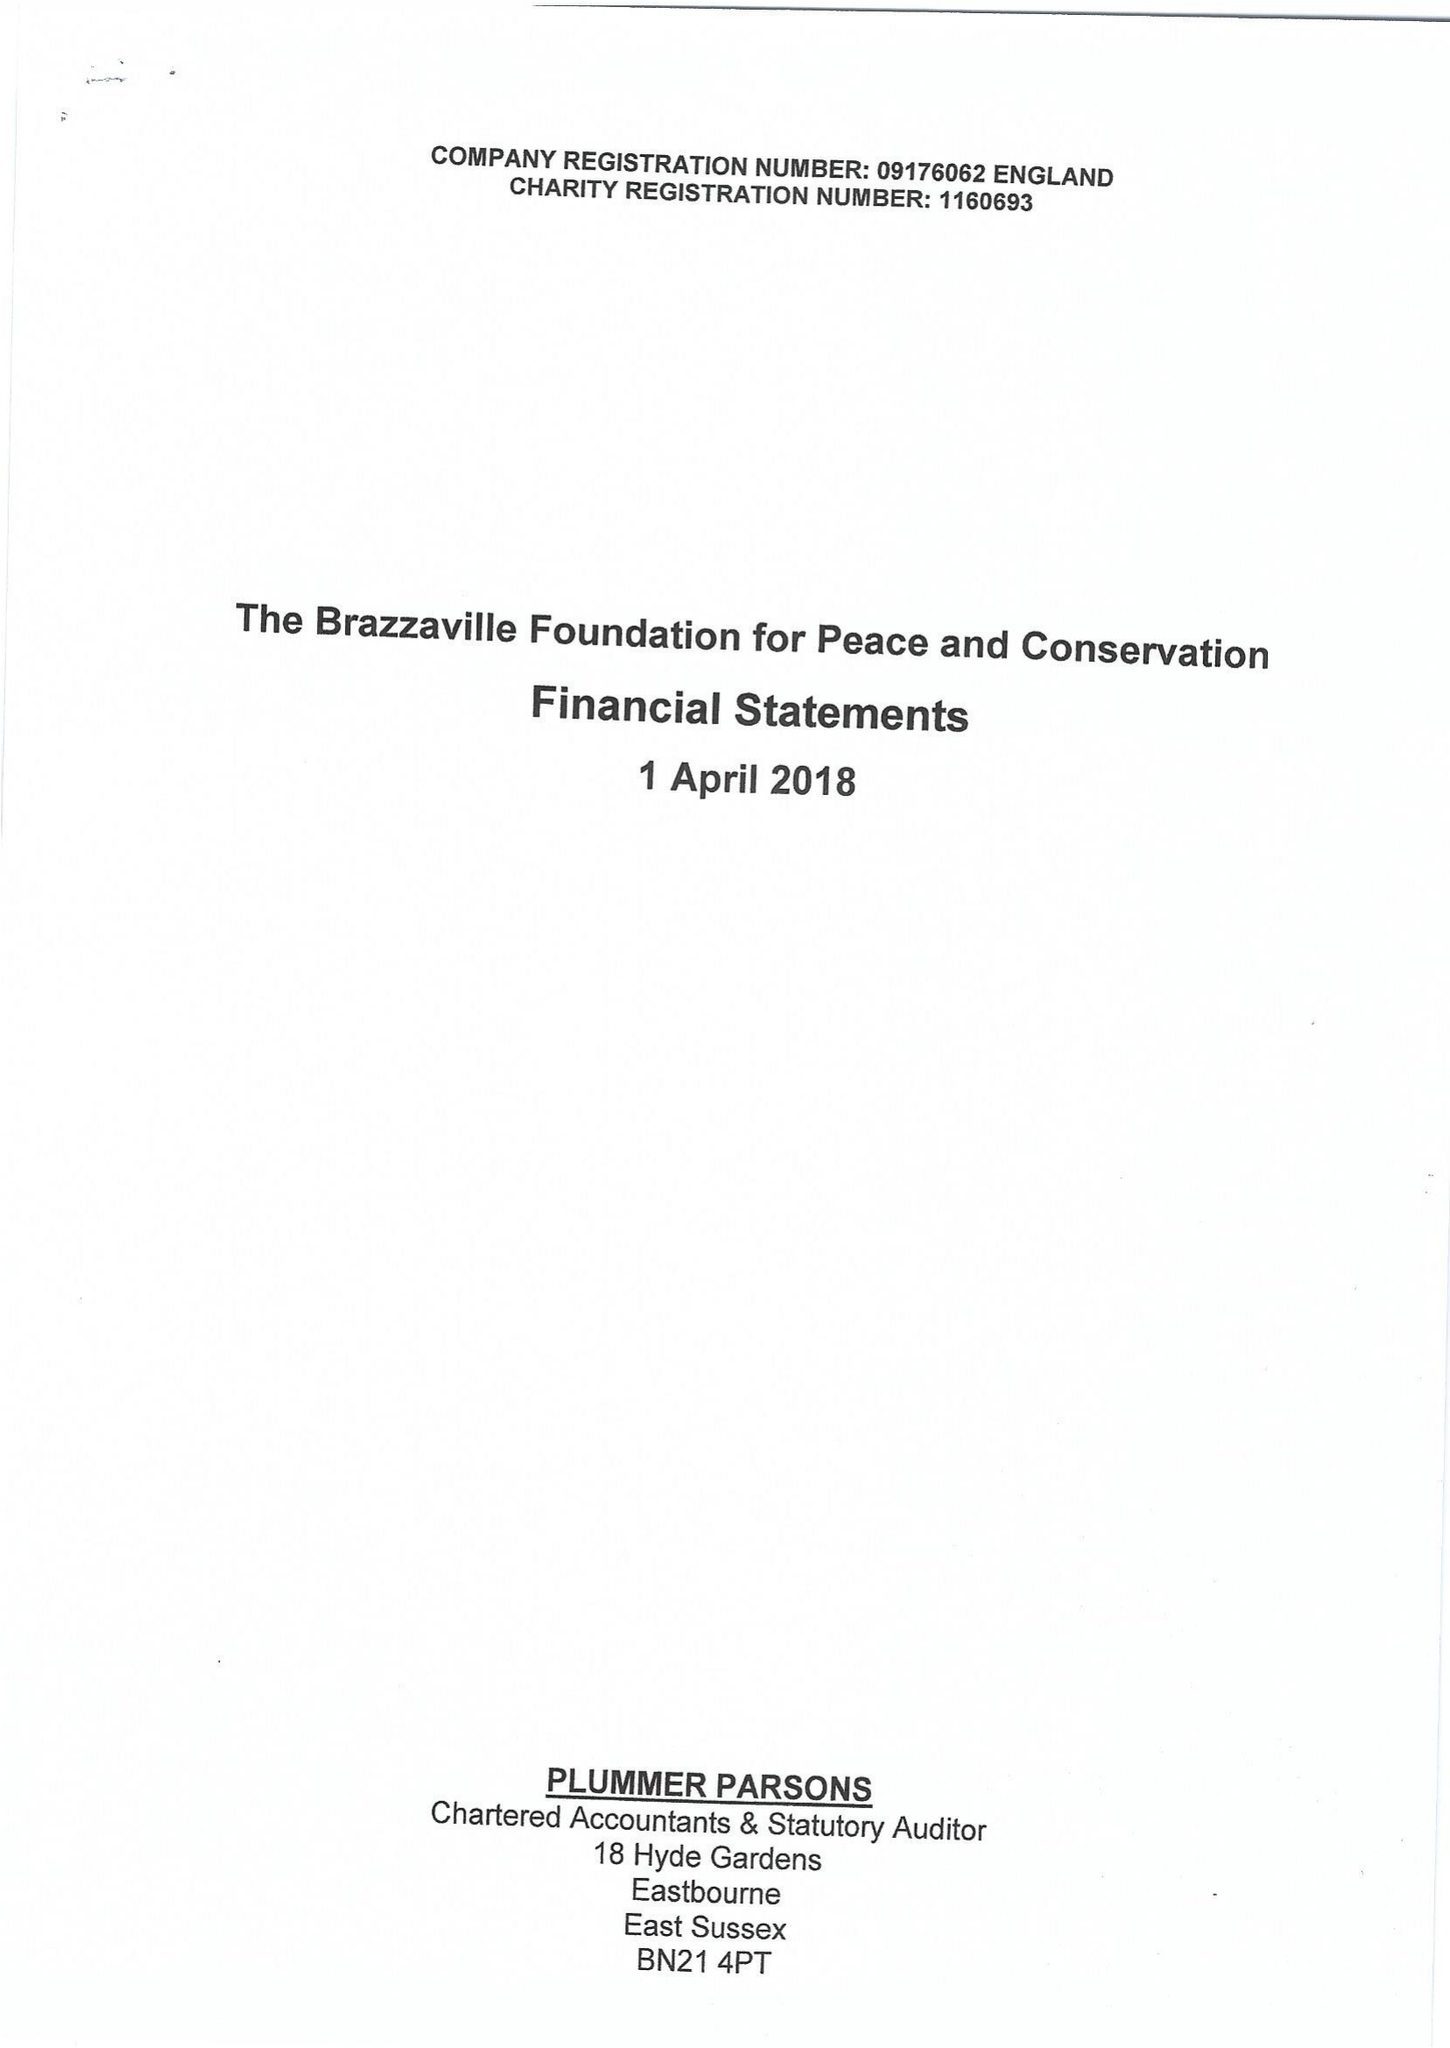What is the value for the report_date?
Answer the question using a single word or phrase. 2018-04-01 